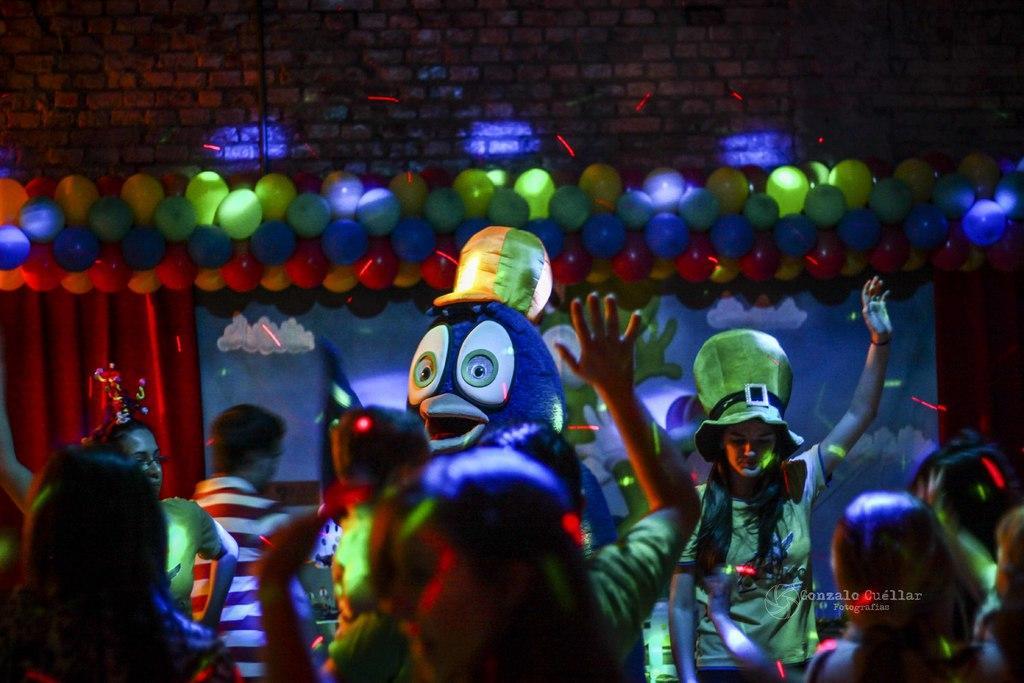Can you describe this image briefly? This picture shows few people standing and we see a woman wearing a cap on her head and we see balloons and a curtain on the back and we see color lights and we see a human wore a mask and a brick wall on the back 